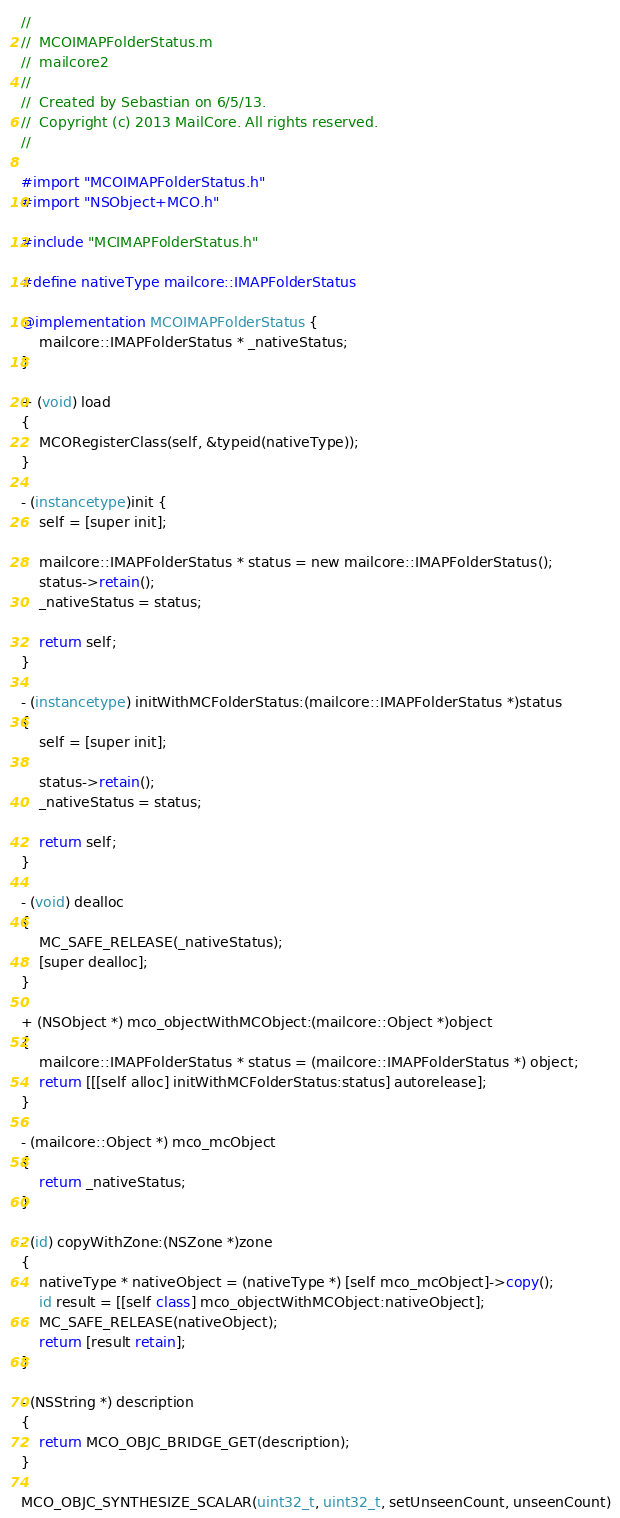<code> <loc_0><loc_0><loc_500><loc_500><_ObjectiveC_>//
//  MCOIMAPFolderStatus.m
//  mailcore2
//
//  Created by Sebastian on 6/5/13.
//  Copyright (c) 2013 MailCore. All rights reserved.
//

#import "MCOIMAPFolderStatus.h"
#import "NSObject+MCO.h"

#include "MCIMAPFolderStatus.h"

#define nativeType mailcore::IMAPFolderStatus

@implementation MCOIMAPFolderStatus {
    mailcore::IMAPFolderStatus * _nativeStatus;
}

+ (void) load
{
    MCORegisterClass(self, &typeid(nativeType));
}

- (instancetype)init {
    self = [super init];
    
    mailcore::IMAPFolderStatus * status = new mailcore::IMAPFolderStatus();
    status->retain();
    _nativeStatus = status;
    
    return self;
}

- (instancetype) initWithMCFolderStatus:(mailcore::IMAPFolderStatus *)status
{
    self = [super init];
    
    status->retain();
    _nativeStatus = status;
    
    return self;
}

- (void) dealloc
{
    MC_SAFE_RELEASE(_nativeStatus);
    [super dealloc];
}

+ (NSObject *) mco_objectWithMCObject:(mailcore::Object *)object
{
    mailcore::IMAPFolderStatus * status = (mailcore::IMAPFolderStatus *) object;
    return [[[self alloc] initWithMCFolderStatus:status] autorelease];
}

- (mailcore::Object *) mco_mcObject
{
    return _nativeStatus;
}

- (id) copyWithZone:(NSZone *)zone
{
    nativeType * nativeObject = (nativeType *) [self mco_mcObject]->copy();
    id result = [[self class] mco_objectWithMCObject:nativeObject];
    MC_SAFE_RELEASE(nativeObject);
    return [result retain];
}

- (NSString *) description
{
    return MCO_OBJC_BRIDGE_GET(description);
}

MCO_OBJC_SYNTHESIZE_SCALAR(uint32_t, uint32_t, setUnseenCount, unseenCount)</code> 